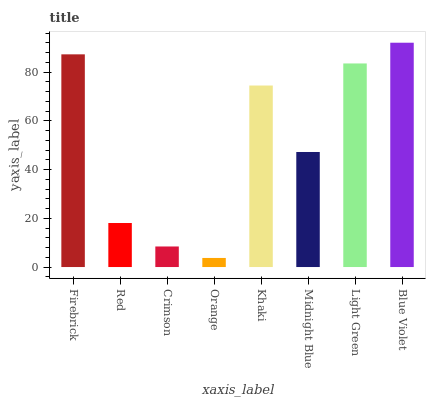Is Orange the minimum?
Answer yes or no. Yes. Is Blue Violet the maximum?
Answer yes or no. Yes. Is Red the minimum?
Answer yes or no. No. Is Red the maximum?
Answer yes or no. No. Is Firebrick greater than Red?
Answer yes or no. Yes. Is Red less than Firebrick?
Answer yes or no. Yes. Is Red greater than Firebrick?
Answer yes or no. No. Is Firebrick less than Red?
Answer yes or no. No. Is Khaki the high median?
Answer yes or no. Yes. Is Midnight Blue the low median?
Answer yes or no. Yes. Is Light Green the high median?
Answer yes or no. No. Is Orange the low median?
Answer yes or no. No. 